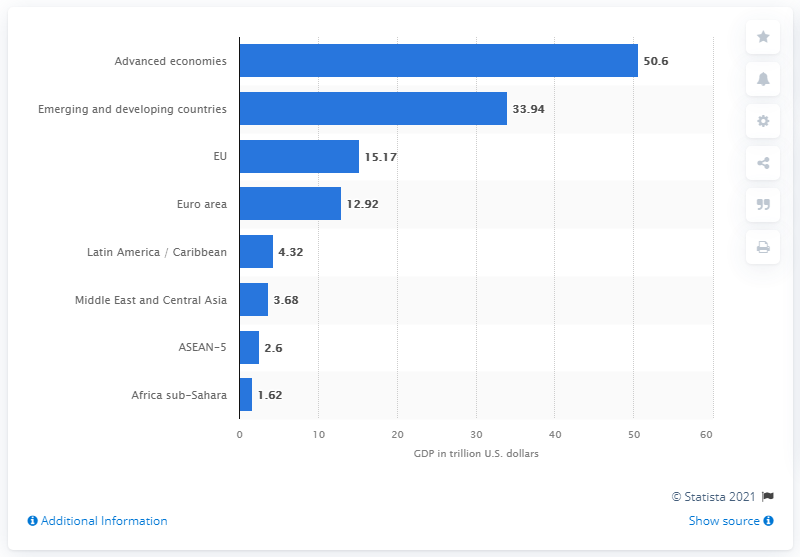List a handful of essential elements in this visual. In 2020, the Gross Domestic Product (GDP) of the industrialized countries was estimated to be 33.94 trillion dollars. 